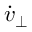<formula> <loc_0><loc_0><loc_500><loc_500>\dot { v } _ { \perp }</formula> 